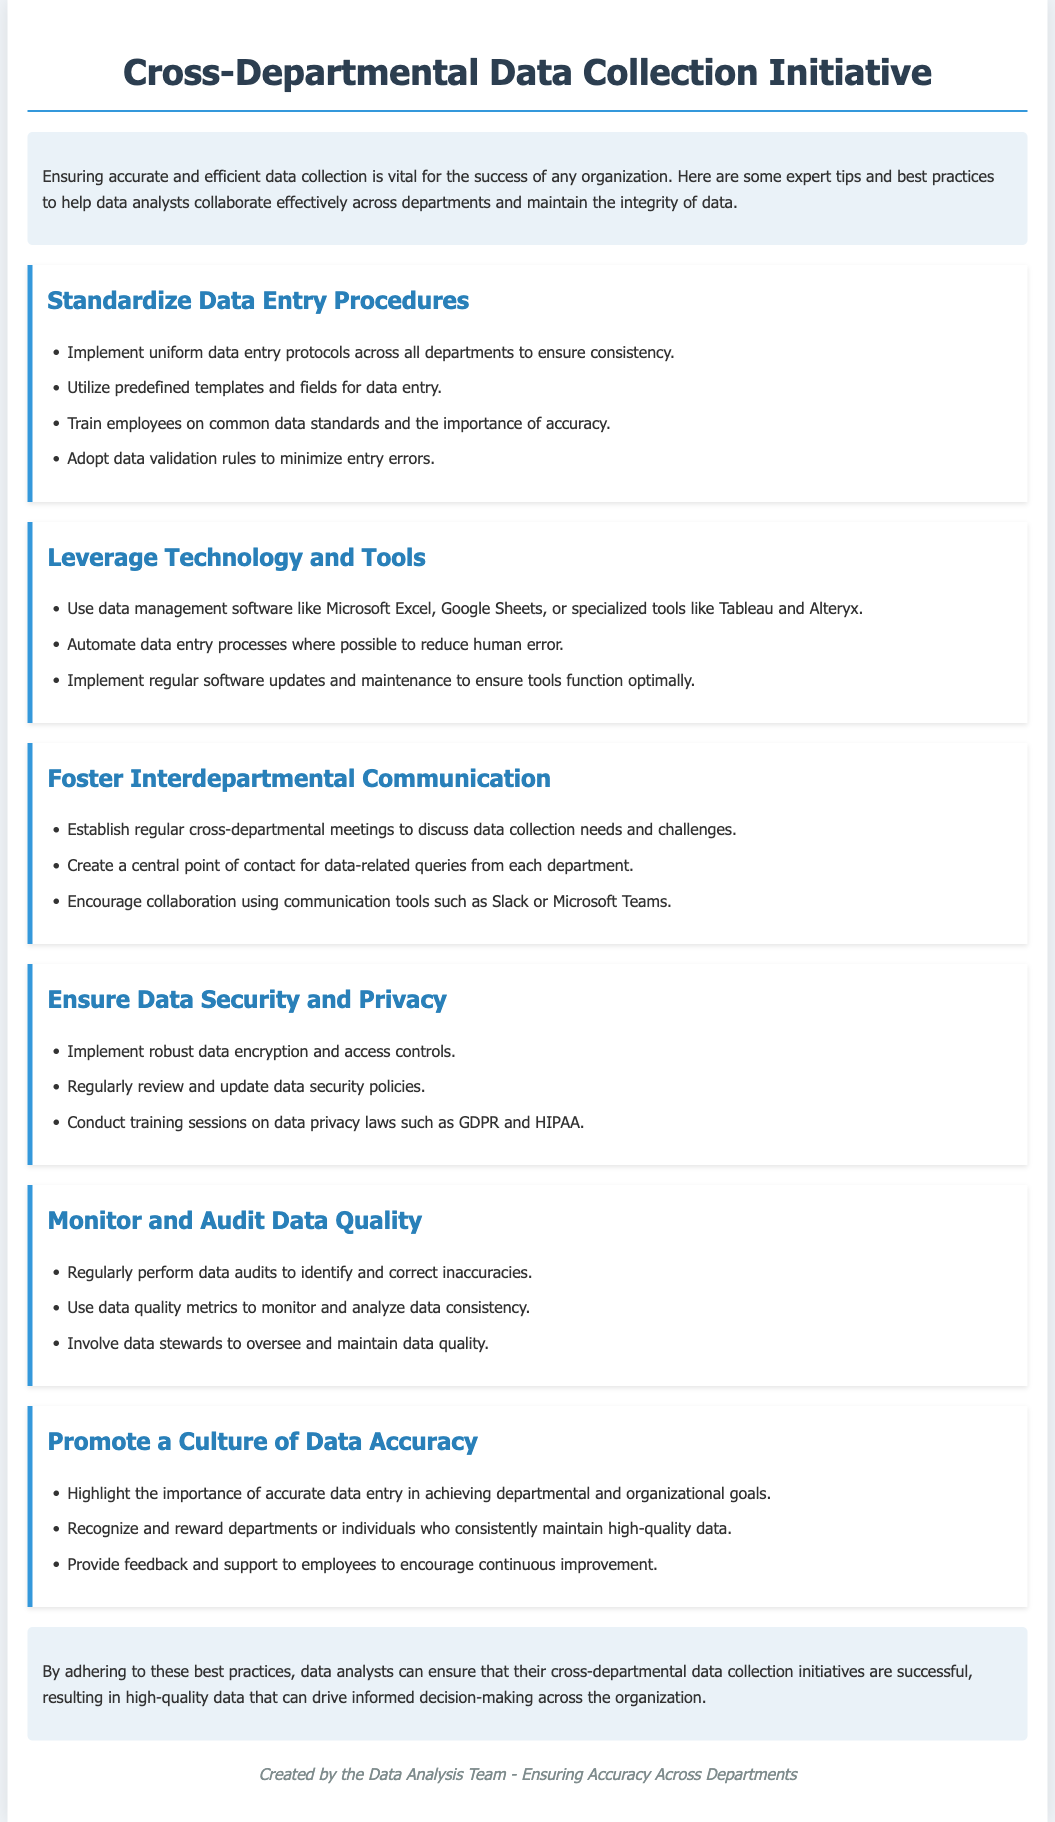What is the title of the initiative? The title of the initiative is stated at the top of the document.
Answer: Cross-Departmental Data Collection Initiative What should departments standardize? The document suggests that departments should standardize their data entry procedures.
Answer: Data entry procedures Name one technology suggested for data management. The document lists several tools, one of which is commonly known as an example.
Answer: Microsoft Excel What is a recommended practice to ensure data security? The document mentions several security practices; one example is mentioned specifically.
Answer: Data encryption How can departments promote data accuracy? The document provides multiple ways, one of which is highlighted in a specific section.
Answer: Recognize and reward departments What is one tool for interdepartmental communication? The document suggests using specific tools for communication between departments, such as one example.
Answer: Slack What is the purpose of data audits mentioned? The reason for performing data audits is detailed in the context of data management.
Answer: Identify and correct inaccuracies What does the conclusion emphasize? The conclusion summarizes the overall aim of adhering to best practices mentioned earlier.
Answer: Successful cross-departmental data collection initiatives 